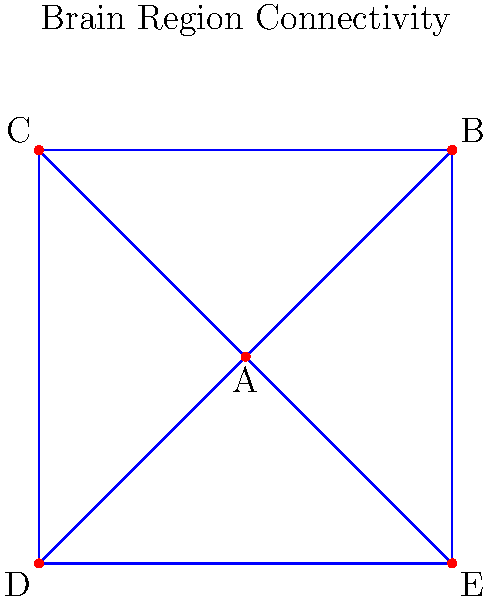In a study of brain connectivity during a complex cognitive task, the graph represents connections between five key brain regions (A, B, C, D, E). If region A is deactivated, what is the minimum number of additional regions that must be deactivated to completely disconnect the network? To solve this problem, we need to analyze the graph's structure and determine the minimum cut set after removing node A. Let's approach this step-by-step:

1. First, observe that node A is already deactivated, so we remove it from consideration.

2. The remaining graph consists of nodes B, C, D, and E.

3. We need to find the minimum number of nodes to remove to disconnect this remaining graph.

4. Notice that the remaining graph forms a cycle: B-C-D-E-B.

5. In a cycle, we need to remove at least two nodes to disconnect the graph completely.

6. Any two adjacent nodes in this cycle would be sufficient. For example, removing B and C would disconnect the graph.

7. There is no way to disconnect the graph by removing only one additional node, as that would leave a path between the other three nodes.

Therefore, the minimum number of additional regions that must be deactivated to completely disconnect the network is 2.
Answer: 2 